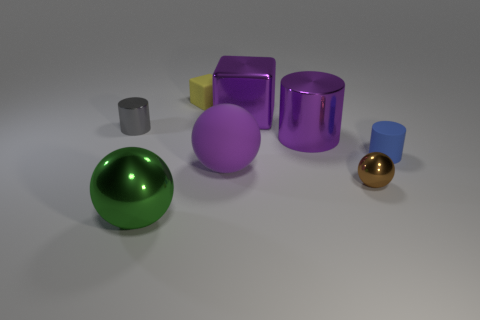Add 1 big red matte cylinders. How many objects exist? 9 Subtract all blocks. How many objects are left? 6 Add 6 purple balls. How many purple balls exist? 7 Subtract 0 green cubes. How many objects are left? 8 Subtract all small yellow rubber things. Subtract all purple cubes. How many objects are left? 6 Add 5 big purple shiny cubes. How many big purple shiny cubes are left? 6 